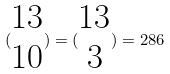Convert formula to latex. <formula><loc_0><loc_0><loc_500><loc_500>( \begin{matrix} 1 3 \\ 1 0 \end{matrix} ) = ( \begin{matrix} 1 3 \\ 3 \end{matrix} ) = 2 8 6</formula> 